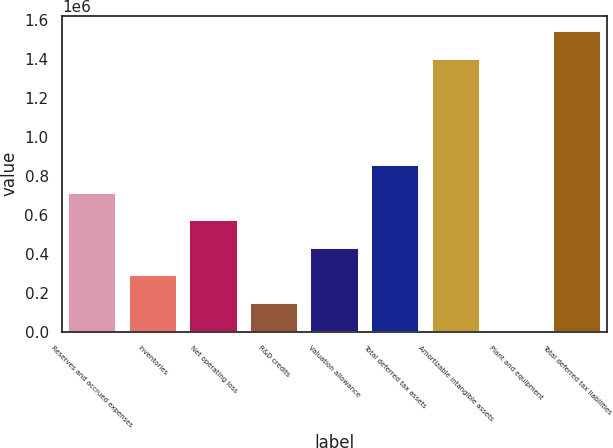Convert chart. <chart><loc_0><loc_0><loc_500><loc_500><bar_chart><fcel>Reserves and accrued expenses<fcel>Inventories<fcel>Net operating loss<fcel>R&D credits<fcel>Valuation allowance<fcel>Total deferred tax assets<fcel>Amortizable intangible assets<fcel>Plant and equipment<fcel>Total deferred tax liabilities<nl><fcel>713456<fcel>289043<fcel>571985<fcel>147573<fcel>430514<fcel>854926<fcel>1.40079e+06<fcel>6102<fcel>1.54226e+06<nl></chart> 